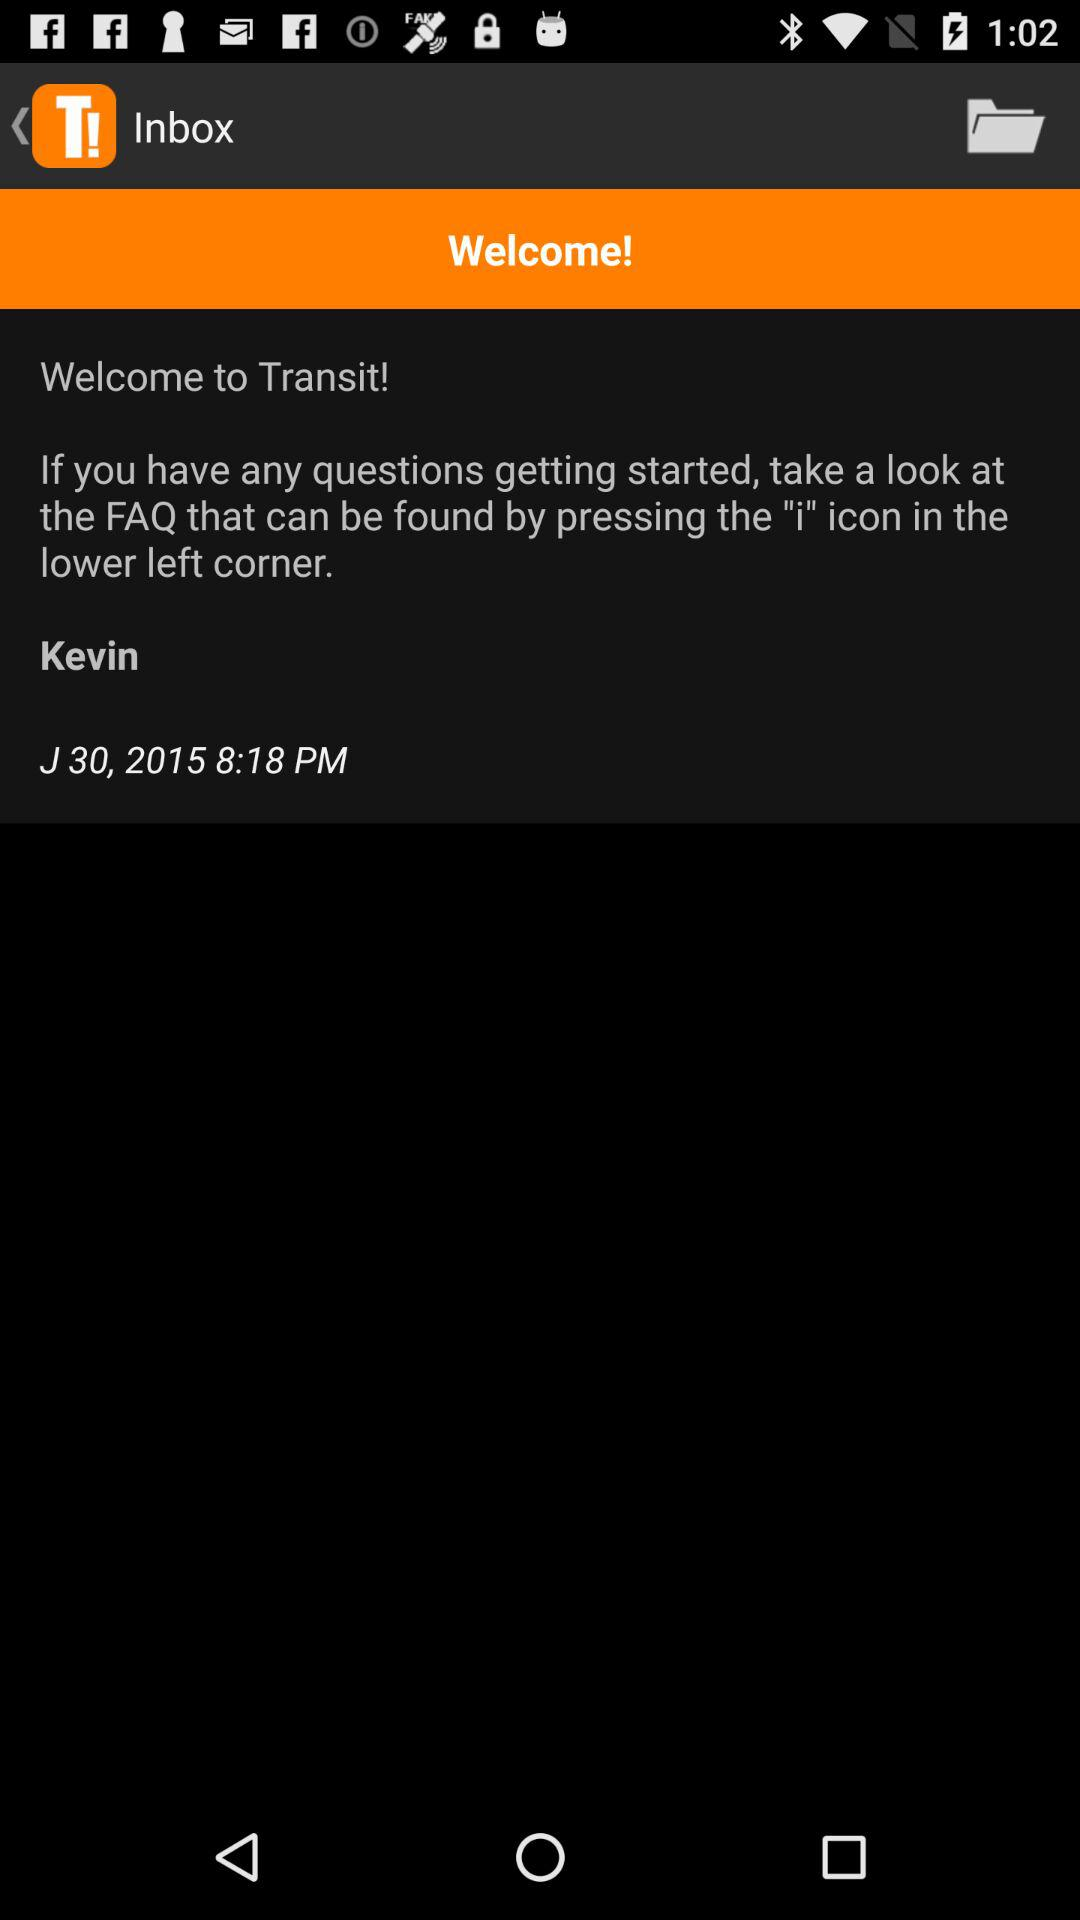What is the date of the message? The date of the message is June 30, 2015. 